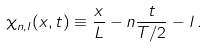Convert formula to latex. <formula><loc_0><loc_0><loc_500><loc_500>\chi _ { n , l } ( x , t ) \equiv \frac { x } { L } - n \frac { t } { T / 2 } - l \, .</formula> 